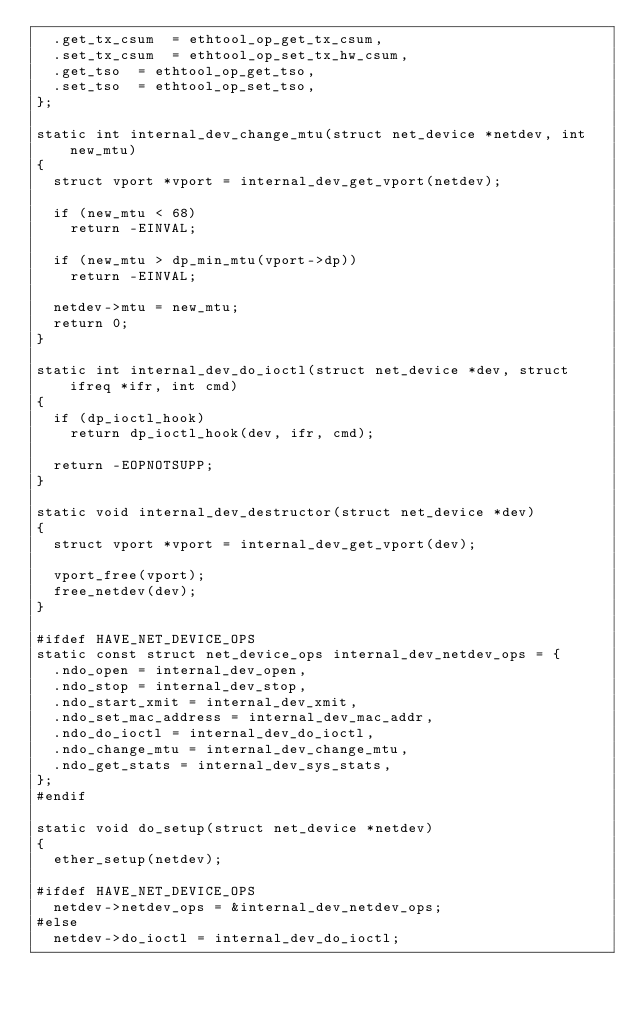Convert code to text. <code><loc_0><loc_0><loc_500><loc_500><_C_>	.get_tx_csum	= ethtool_op_get_tx_csum,
	.set_tx_csum	= ethtool_op_set_tx_hw_csum,
	.get_tso	= ethtool_op_get_tso,
	.set_tso	= ethtool_op_set_tso,
};

static int internal_dev_change_mtu(struct net_device *netdev, int new_mtu)
{
	struct vport *vport = internal_dev_get_vport(netdev);

	if (new_mtu < 68)
		return -EINVAL;

	if (new_mtu > dp_min_mtu(vport->dp))
		return -EINVAL;

	netdev->mtu = new_mtu;
	return 0;
}

static int internal_dev_do_ioctl(struct net_device *dev, struct ifreq *ifr, int cmd)
{
	if (dp_ioctl_hook)
		return dp_ioctl_hook(dev, ifr, cmd);

	return -EOPNOTSUPP;
}

static void internal_dev_destructor(struct net_device *dev)
{
	struct vport *vport = internal_dev_get_vport(dev);

	vport_free(vport);
	free_netdev(dev);
}

#ifdef HAVE_NET_DEVICE_OPS
static const struct net_device_ops internal_dev_netdev_ops = {
	.ndo_open = internal_dev_open,
	.ndo_stop = internal_dev_stop,
	.ndo_start_xmit = internal_dev_xmit,
	.ndo_set_mac_address = internal_dev_mac_addr,
	.ndo_do_ioctl = internal_dev_do_ioctl,
	.ndo_change_mtu = internal_dev_change_mtu,
	.ndo_get_stats = internal_dev_sys_stats,
};
#endif

static void do_setup(struct net_device *netdev)
{
	ether_setup(netdev);

#ifdef HAVE_NET_DEVICE_OPS
	netdev->netdev_ops = &internal_dev_netdev_ops;
#else
	netdev->do_ioctl = internal_dev_do_ioctl;</code> 